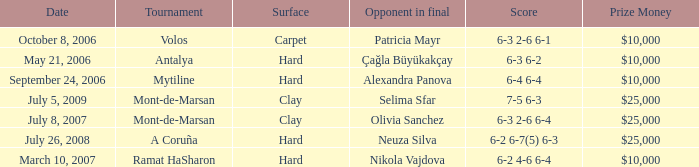What is the score of the hard court Ramat Hasharon tournament? 6-2 4-6 6-4. 